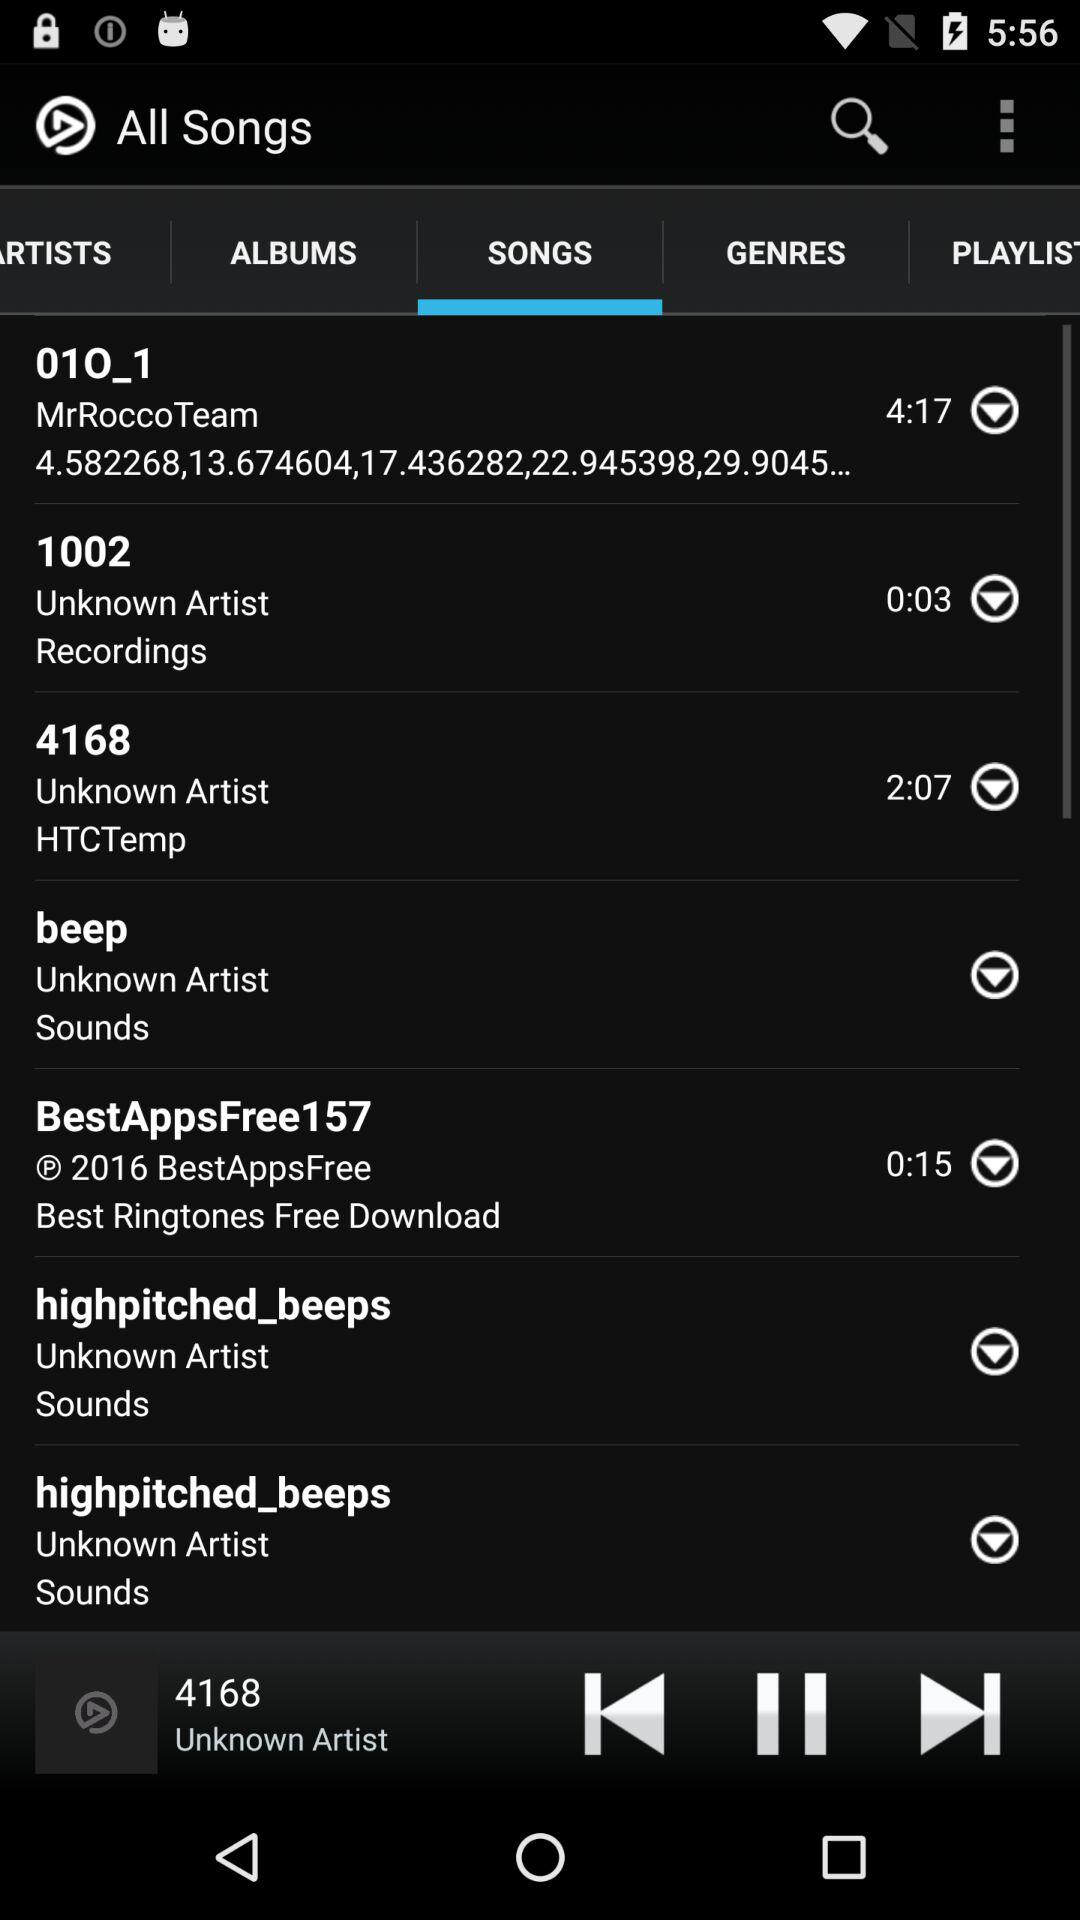What is the duration of "BestAppsFree157"? The duration is 15 seconds. 